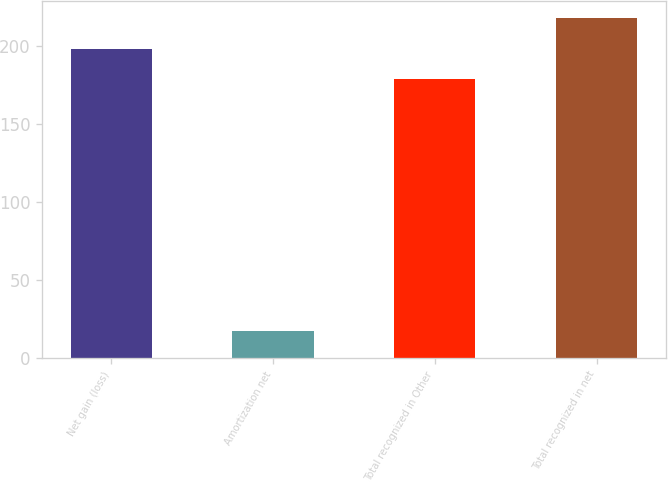Convert chart. <chart><loc_0><loc_0><loc_500><loc_500><bar_chart><fcel>Net gain (loss)<fcel>Amortization net<fcel>Total recognized in Other<fcel>Total recognized in net<nl><fcel>198.5<fcel>17<fcel>179<fcel>218<nl></chart> 